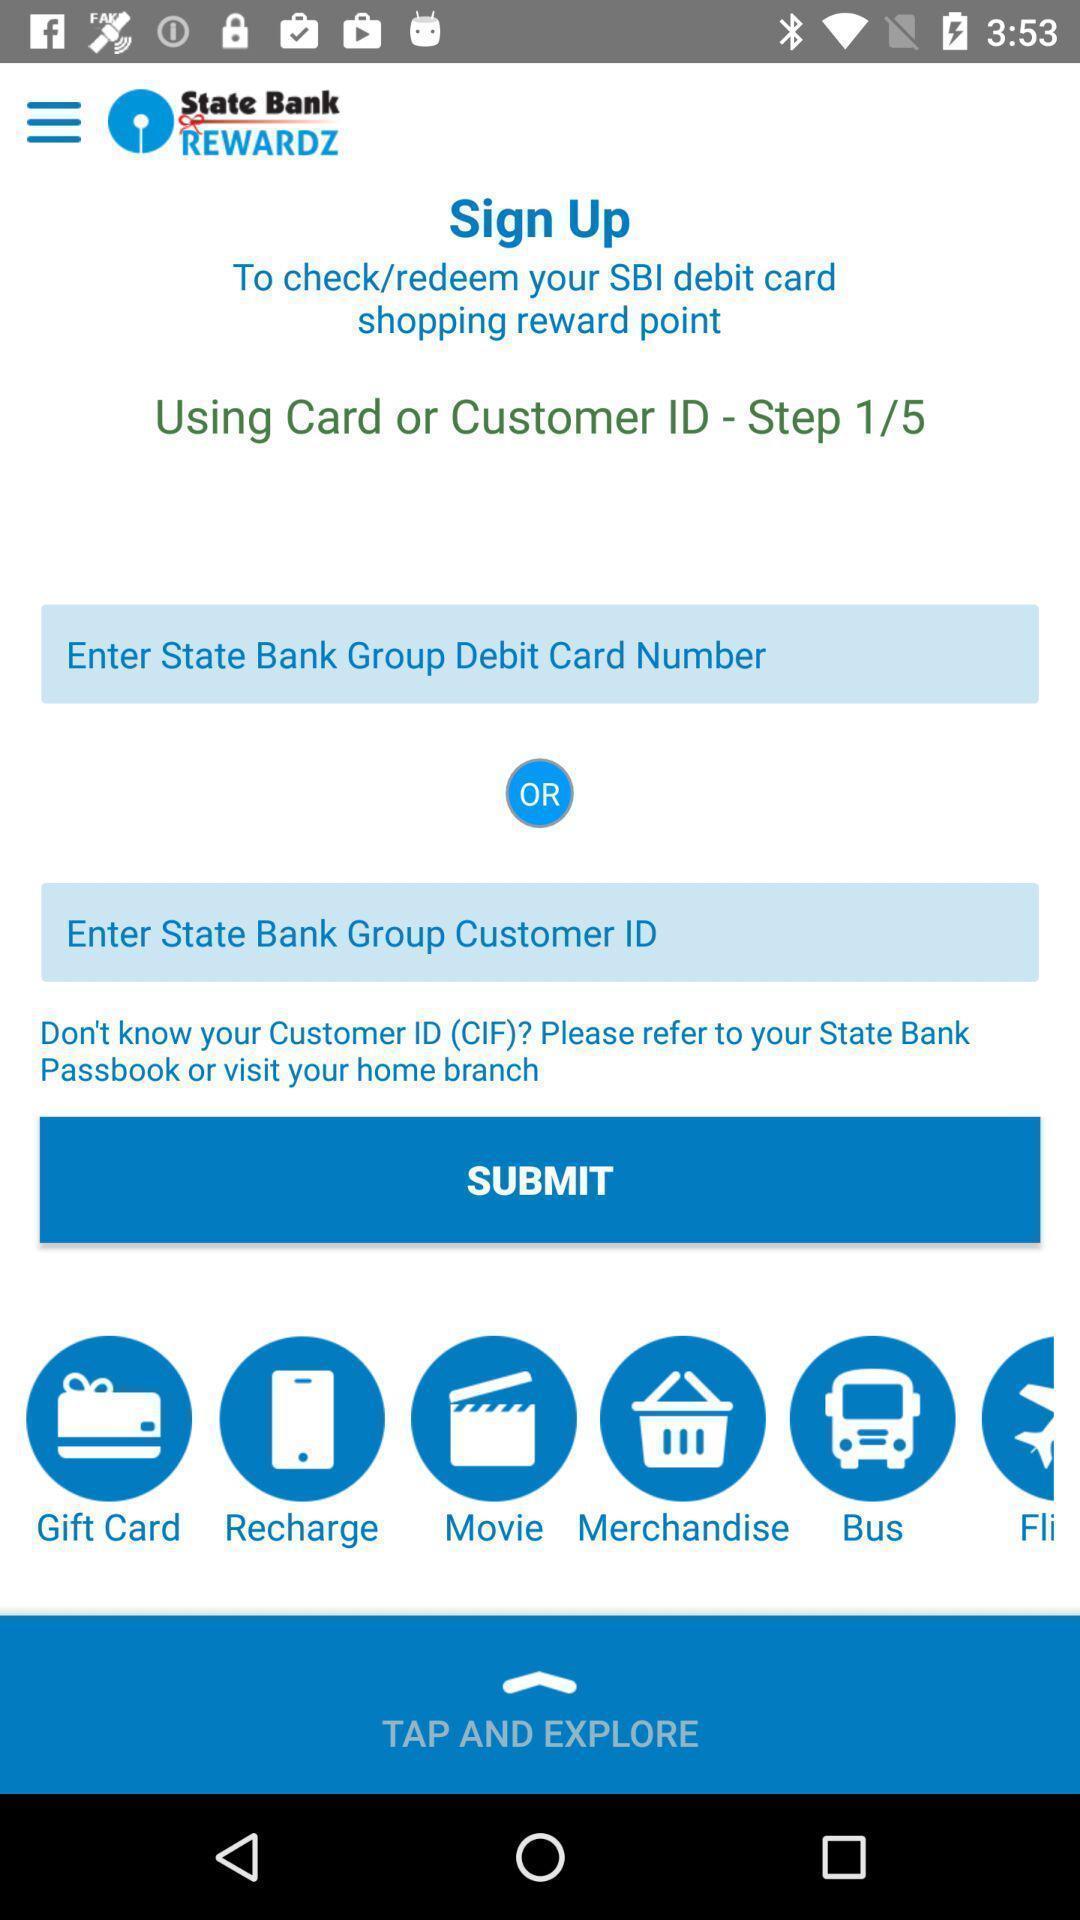What is the overall content of this screenshot? Sign up page. 